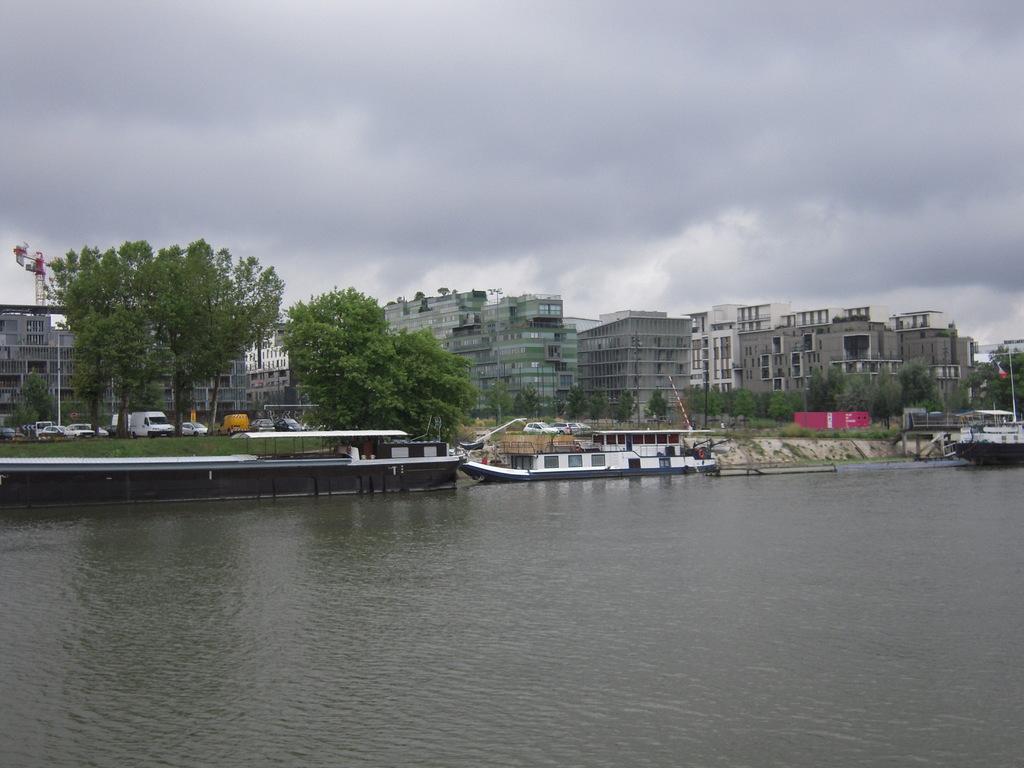Can you describe this image briefly? This is the picture of a city. There are buildings, trees and there are vehicles. On the left side of the image there is a crane. In the foreground there are boats on the water and there is a flag on the boat. At the top sky is cloudy. At the bottom there is water. 